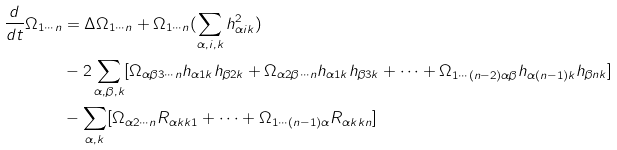Convert formula to latex. <formula><loc_0><loc_0><loc_500><loc_500>\frac { d } { d t } \Omega _ { 1 \cdots n } & = \Delta \Omega _ { 1 \cdots n } + \Omega _ { 1 \cdots n } ( \sum _ { \alpha , i , k } h _ { \alpha i k } ^ { 2 } ) \\ & - 2 \sum _ { \alpha , \beta , k } [ \Omega _ { \alpha \beta 3 \cdots n } h _ { \alpha 1 k } h _ { \beta 2 k } + \Omega _ { \alpha 2 \beta \cdots n } h _ { \alpha 1 k } h _ { \beta 3 k } + \cdots + \Omega _ { 1 \cdots ( n - 2 ) \alpha \beta } h _ { \alpha ( n - 1 ) k } h _ { \beta n k } ] \\ & - \sum _ { \alpha , k } [ \Omega _ { \alpha 2 \cdots n } R _ { \alpha k k 1 } + \cdots + \Omega _ { 1 \cdots ( n - 1 ) \alpha } R _ { \alpha k k n } ]</formula> 